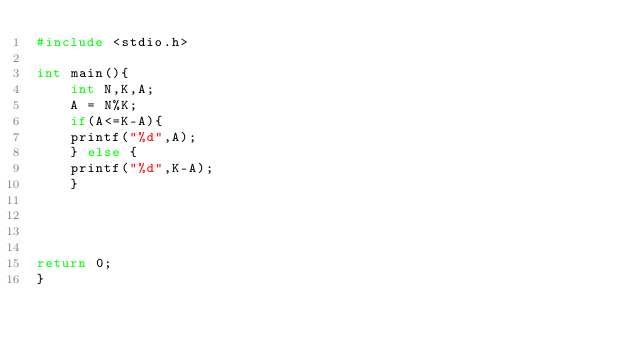Convert code to text. <code><loc_0><loc_0><loc_500><loc_500><_C_>#include <stdio.h>

int main(){
	int N,K,A;
	A = N%K;
    if(A<=K-A){
    printf("%d",A);
    } else {
    printf("%d",K-A);
    }




return 0;
}</code> 